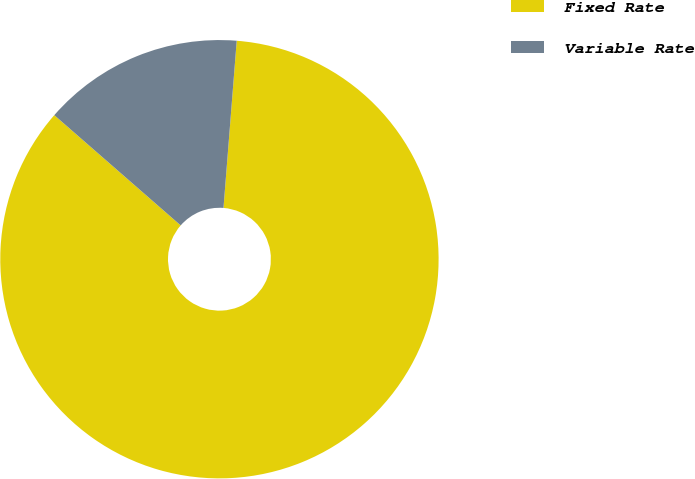<chart> <loc_0><loc_0><loc_500><loc_500><pie_chart><fcel>Fixed Rate<fcel>Variable Rate<nl><fcel>85.16%<fcel>14.84%<nl></chart> 